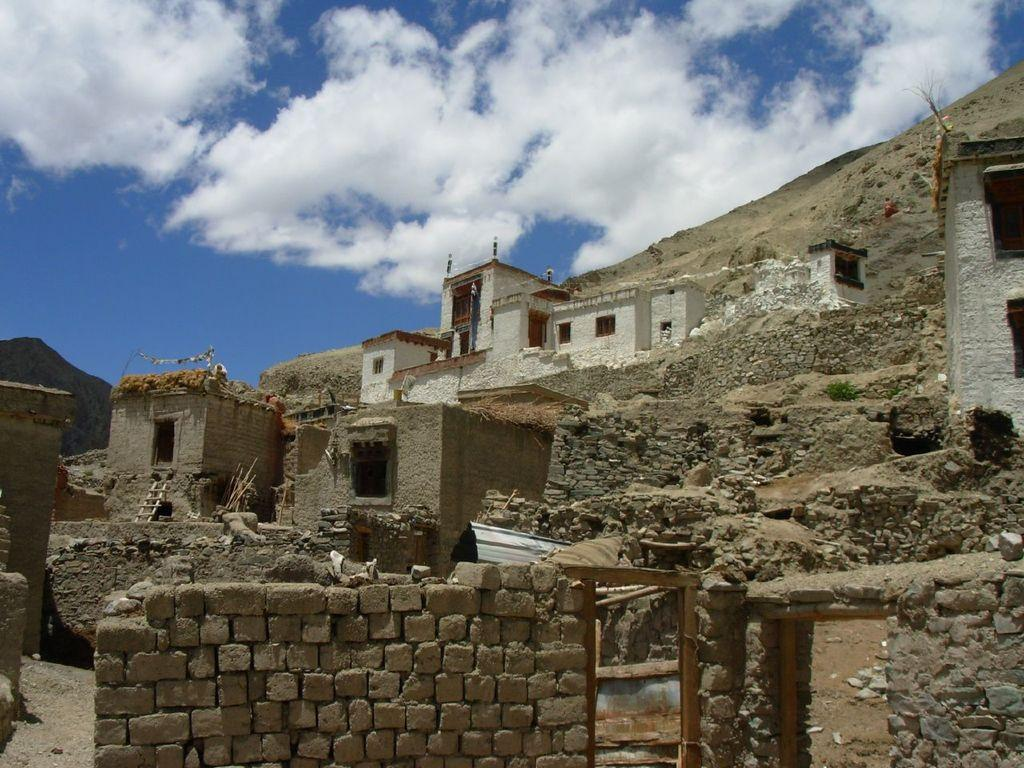What type of structure is visible in the image? There is a brick wall in the image. What else can be seen in the image besides the brick wall? There are buildings, a ladder, wooden sticks, and other objects in the image. Where is the ladder positioned in the image? The ladder is in the image, but its exact position cannot be determined from the provided facts. What is visible in the sky at the top of the image? There are clouds in the sky at the top of the image. Can you tell me what type of doctor is treating the squirrel in the image? There is no squirrel or doctor present in the image. What color is the canvas that the ladder is leaning against in the image? There is no canvas present in the image. 